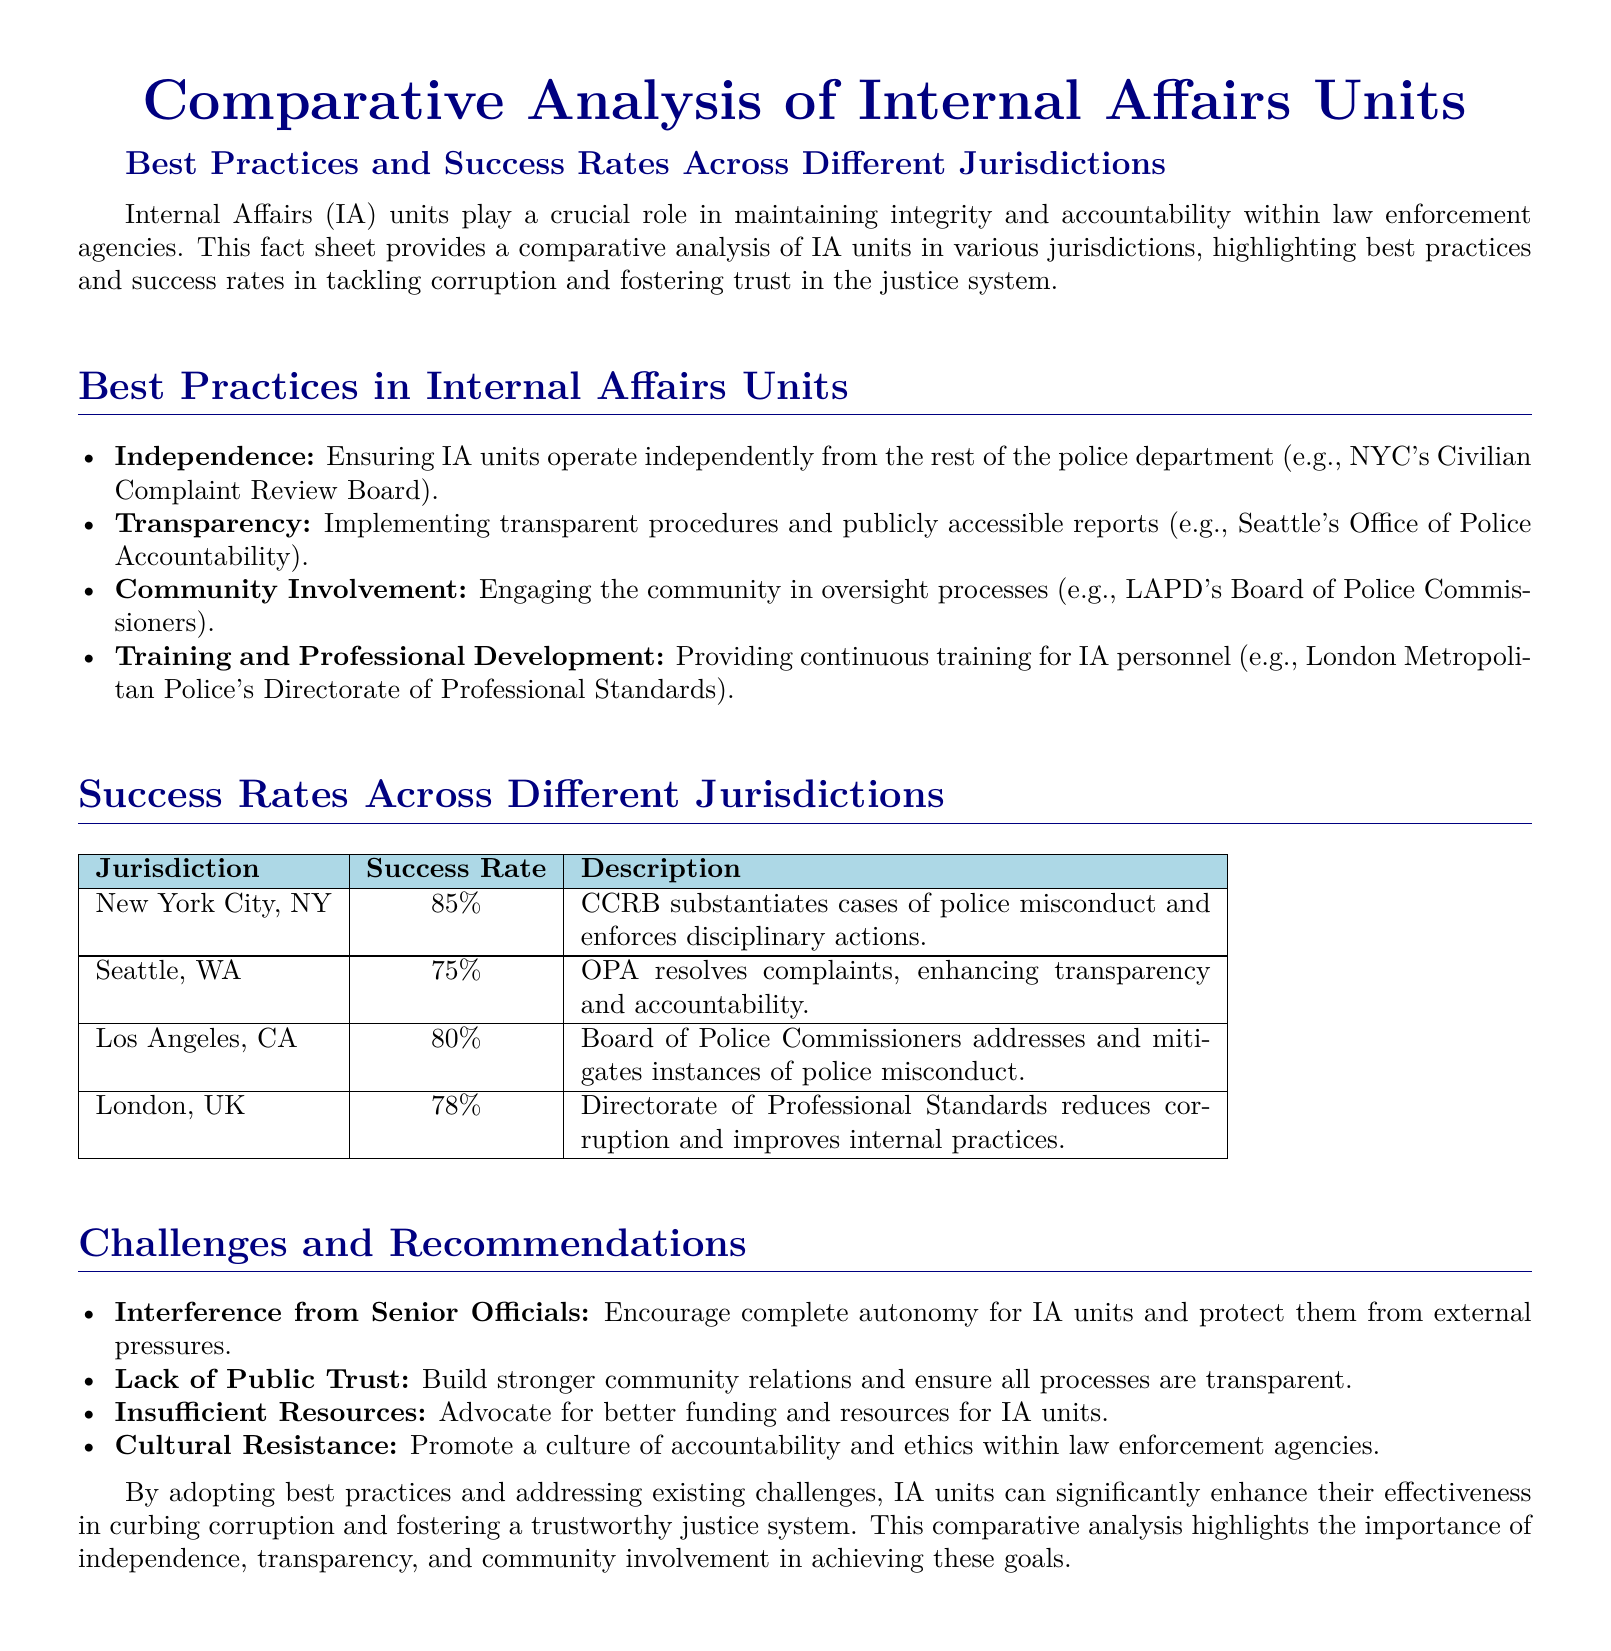What is the title of the document? The title is stated at the beginning of the document and emphasizes the focus on internal affairs units.
Answer: Comparative Analysis of Internal Affairs Units What practice is highlighted for ensuring IA units operate independently? The document provides a specific example of NYC’s Civilian Complaint Review Board that exemplifies independence.
Answer: Independence What percentage is the success rate for New York City? The success rates are listed for various jurisdictions, with NYC having a specific figure.
Answer: 85% Which jurisdiction has a success rate of 75%? The success rates in the document are enumerated by jurisdiction.
Answer: Seattle, WA What is one of the challenges faced by Internal Affairs units? The document lists several challenges, indicating the difficulties IA units encounter.
Answer: Insufficient Resources What is emphasized as a best practice for IA units in terms of community relations? The section highlights best practices that include community engagement in oversight processes.
Answer: Community Involvement How does the success rate of the London Metropolitan Police's Directorate of Professional Standards compare to that of Seattle? The document states both success rates, allowing for a direct comparison.
Answer: Lower What is recommended to combat interference from senior officials? The recommendations section addresses ways to enhance the autonomy of IA units.
Answer: Complete autonomy What unique feature does the Seattle Office of Police Accountability implement? The document mentions a specific characteristic that enhances accountability in Seattle.
Answer: Transparent procedures 